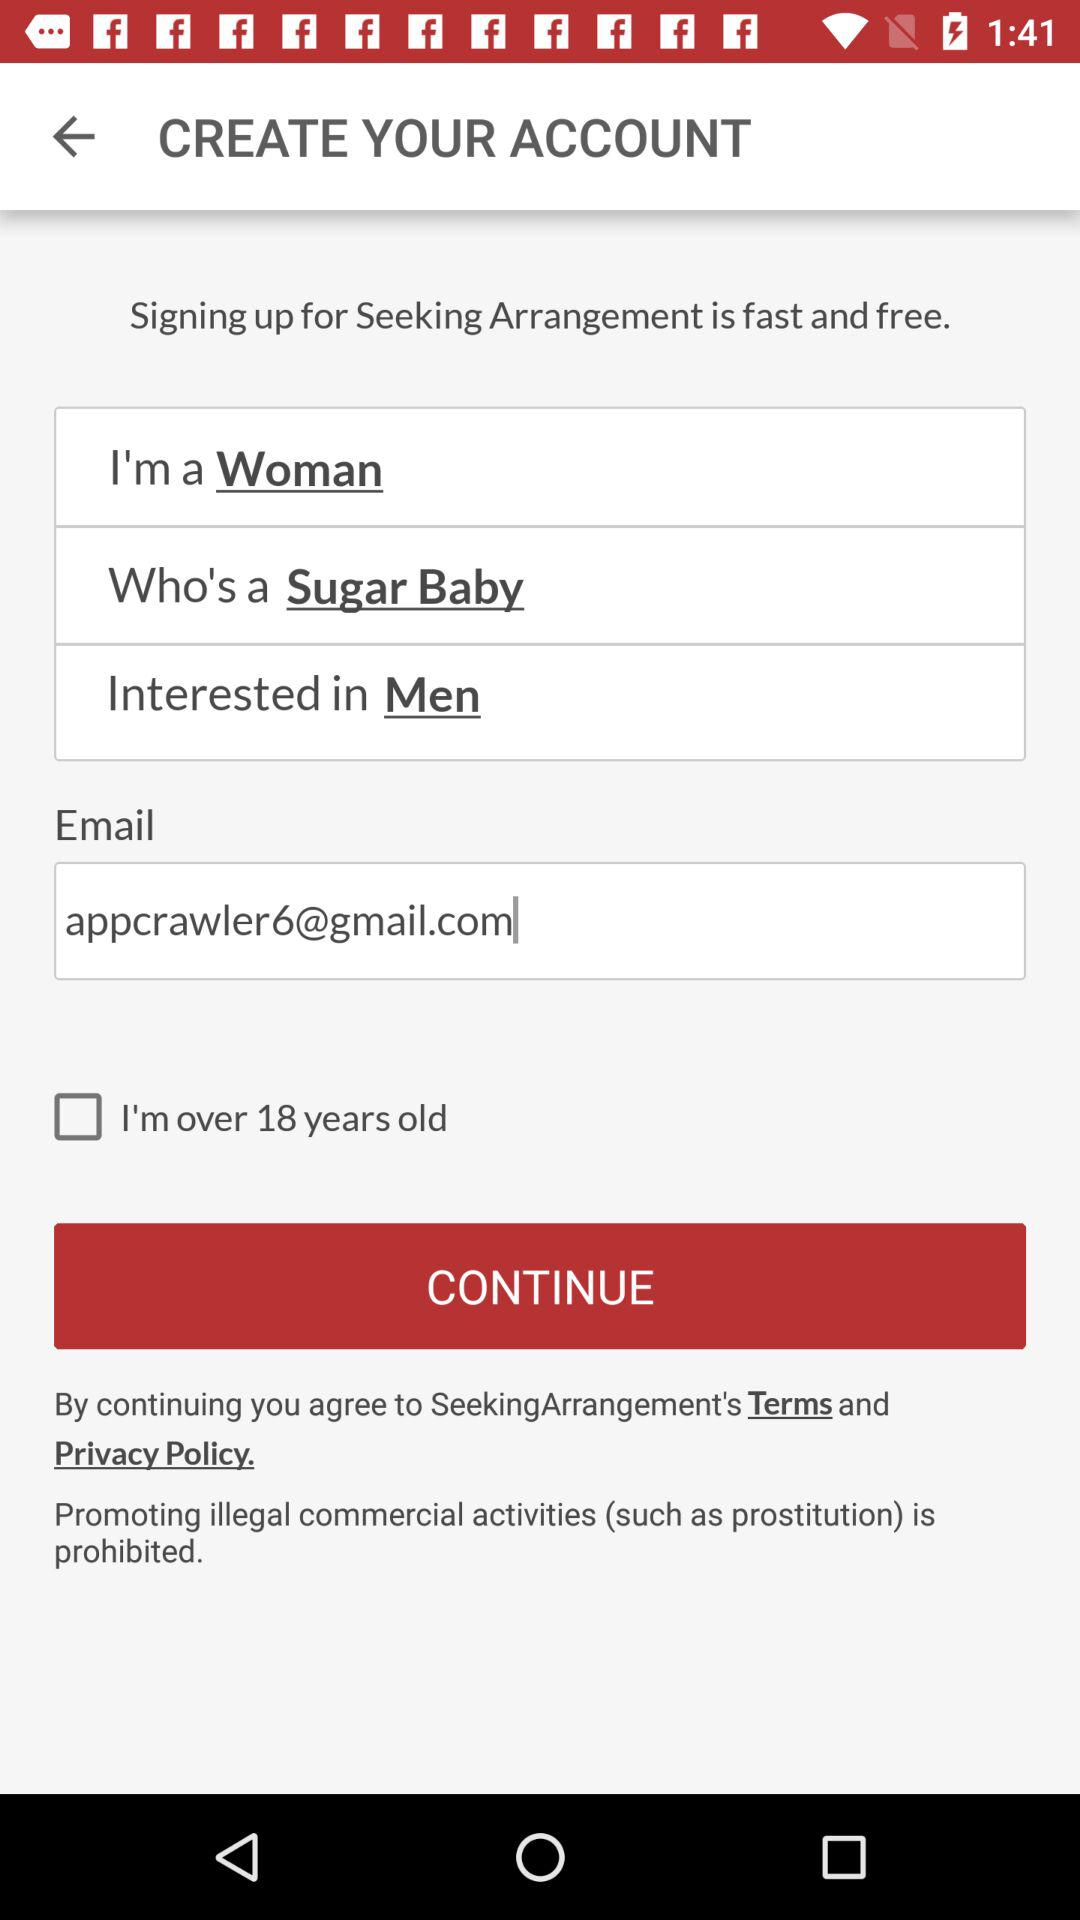What is the gender of the user? The user is a woman. 